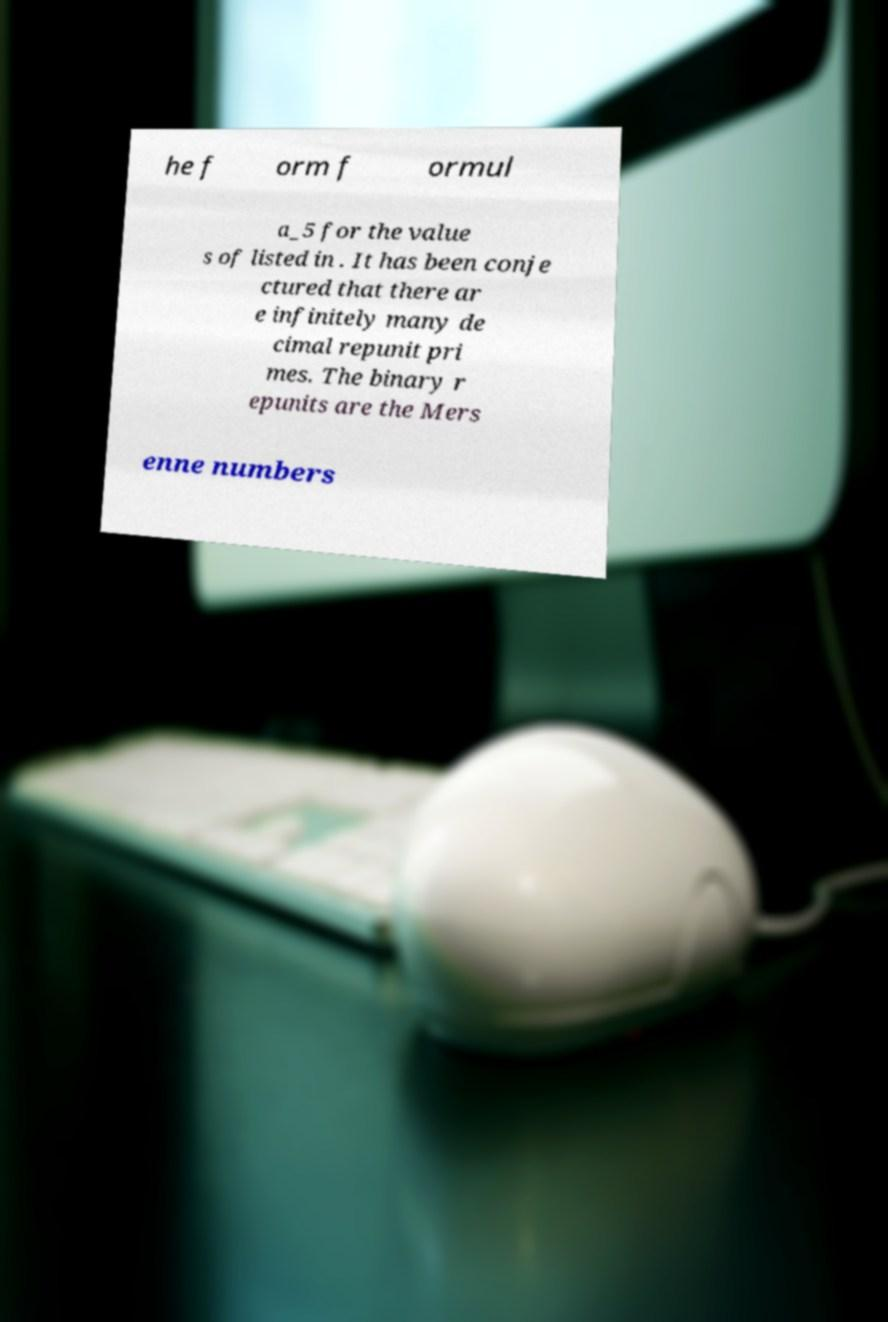Can you accurately transcribe the text from the provided image for me? he f orm f ormul a_5 for the value s of listed in . It has been conje ctured that there ar e infinitely many de cimal repunit pri mes. The binary r epunits are the Mers enne numbers 